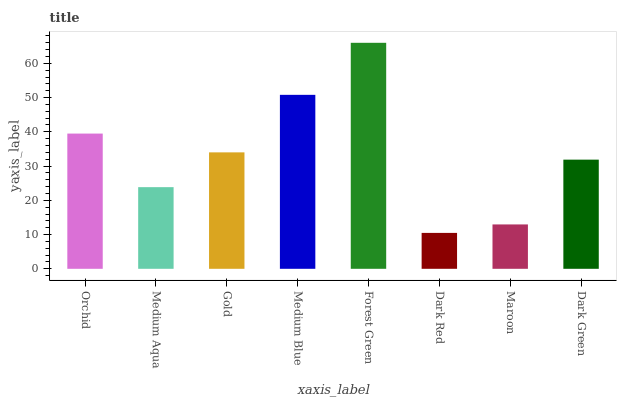Is Medium Aqua the minimum?
Answer yes or no. No. Is Medium Aqua the maximum?
Answer yes or no. No. Is Orchid greater than Medium Aqua?
Answer yes or no. Yes. Is Medium Aqua less than Orchid?
Answer yes or no. Yes. Is Medium Aqua greater than Orchid?
Answer yes or no. No. Is Orchid less than Medium Aqua?
Answer yes or no. No. Is Gold the high median?
Answer yes or no. Yes. Is Dark Green the low median?
Answer yes or no. Yes. Is Maroon the high median?
Answer yes or no. No. Is Medium Blue the low median?
Answer yes or no. No. 